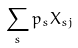Convert formula to latex. <formula><loc_0><loc_0><loc_500><loc_500>\sum _ { s } p _ { s } X _ { s j }</formula> 